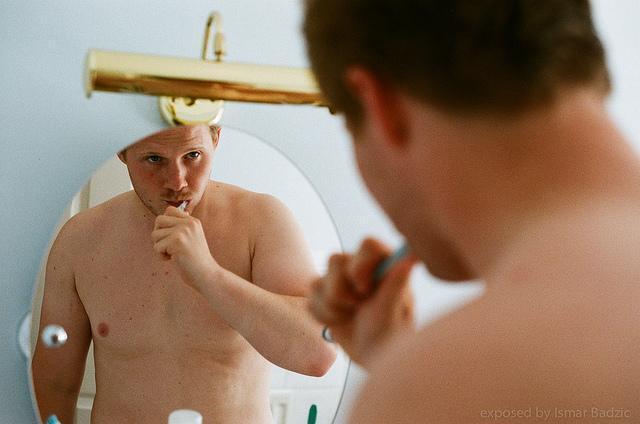How many people are there?
Give a very brief answer. 2. How many trucks are parked on the road?
Give a very brief answer. 0. 